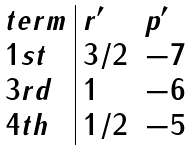Convert formula to latex. <formula><loc_0><loc_0><loc_500><loc_500>\begin{array} { l | l l } t e r m & r ^ { \prime } & p ^ { \prime } \\ 1 s t & 3 / 2 & - 7 \\ 3 r d & 1 & - 6 \\ 4 t h & 1 / 2 & - 5 \end{array}</formula> 